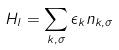Convert formula to latex. <formula><loc_0><loc_0><loc_500><loc_500>H _ { l } = \sum _ { k , \sigma } \epsilon _ { k } n _ { k , \sigma }</formula> 